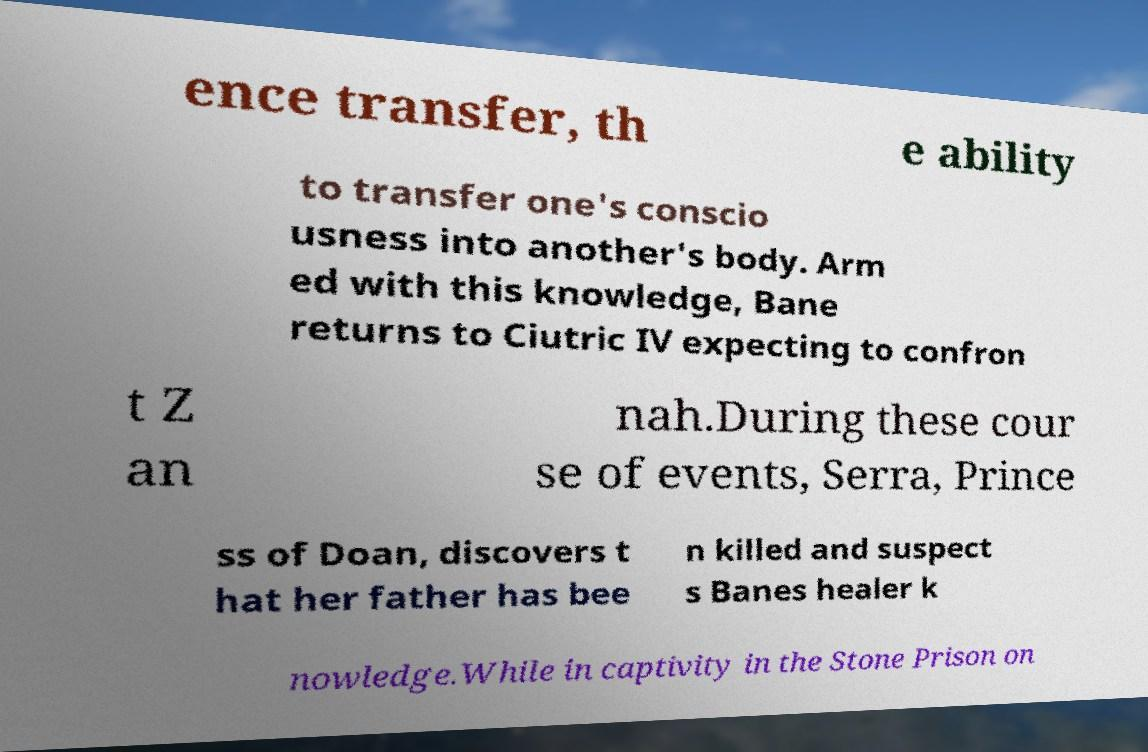For documentation purposes, I need the text within this image transcribed. Could you provide that? ence transfer, th e ability to transfer one's conscio usness into another's body. Arm ed with this knowledge, Bane returns to Ciutric IV expecting to confron t Z an nah.During these cour se of events, Serra, Prince ss of Doan, discovers t hat her father has bee n killed and suspect s Banes healer k nowledge.While in captivity in the Stone Prison on 